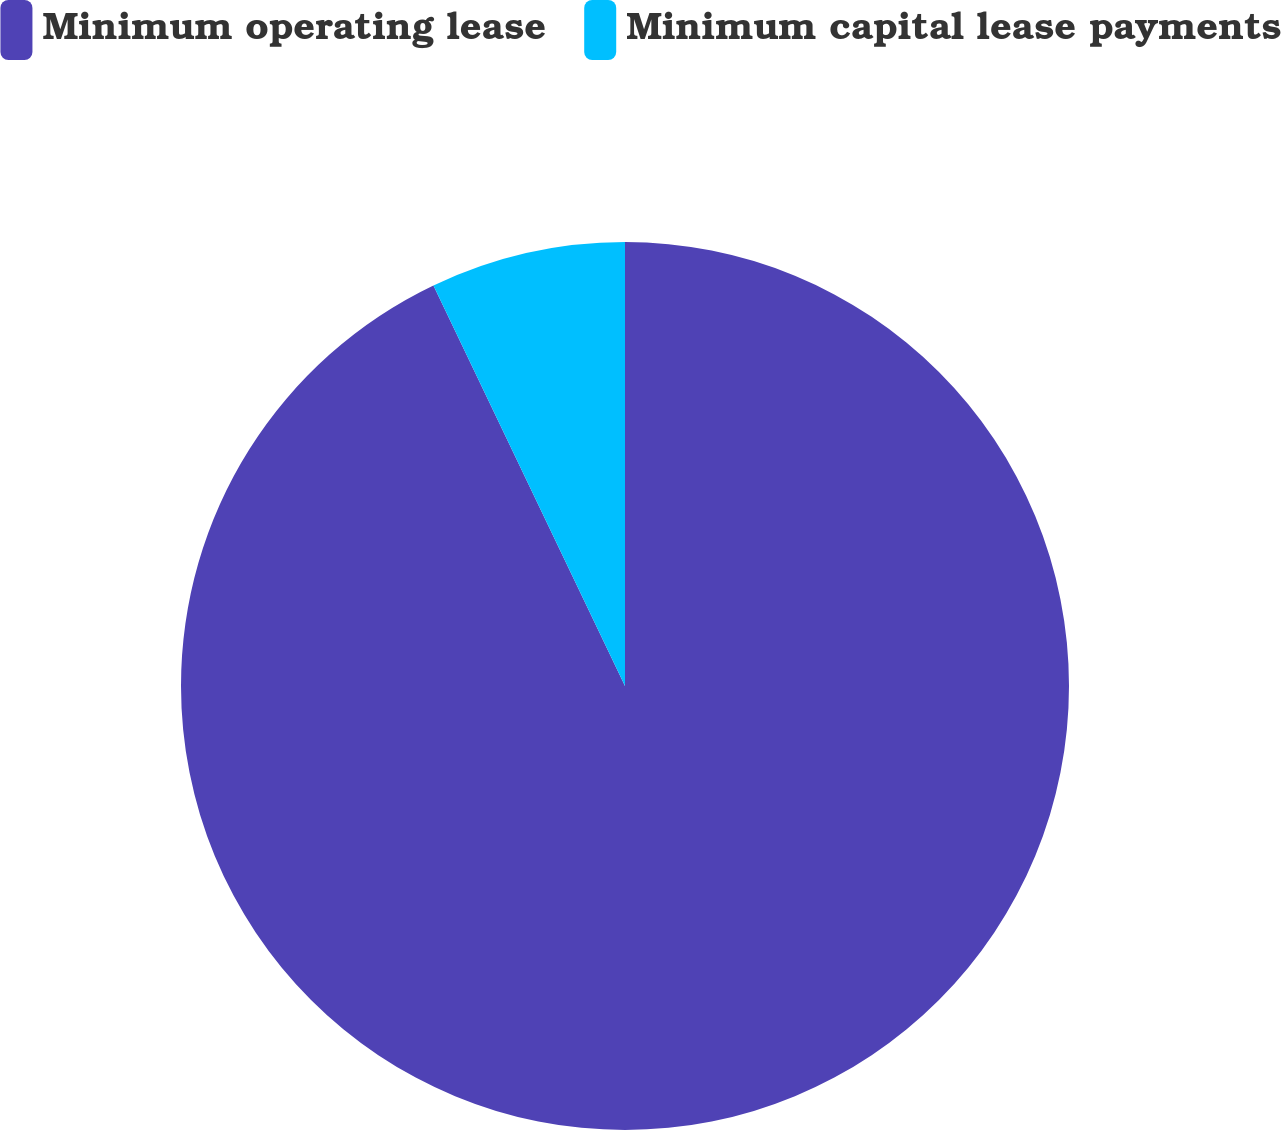Convert chart. <chart><loc_0><loc_0><loc_500><loc_500><pie_chart><fcel>Minimum operating lease<fcel>Minimum capital lease payments<nl><fcel>92.9%<fcel>7.1%<nl></chart> 